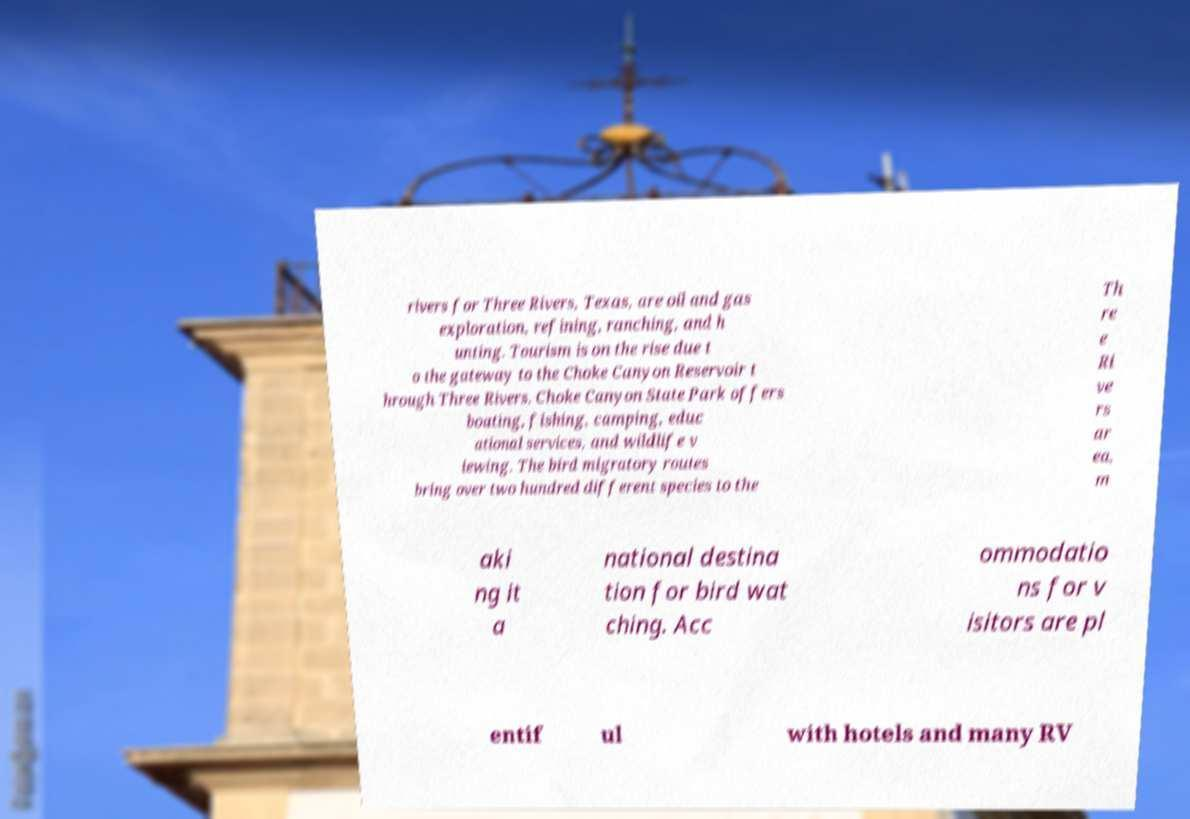Could you assist in decoding the text presented in this image and type it out clearly? rivers for Three Rivers, Texas, are oil and gas exploration, refining, ranching, and h unting. Tourism is on the rise due t o the gateway to the Choke Canyon Reservoir t hrough Three Rivers. Choke Canyon State Park offers boating, fishing, camping, educ ational services, and wildlife v iewing. The bird migratory routes bring over two hundred different species to the Th re e Ri ve rs ar ea, m aki ng it a national destina tion for bird wat ching. Acc ommodatio ns for v isitors are pl entif ul with hotels and many RV 